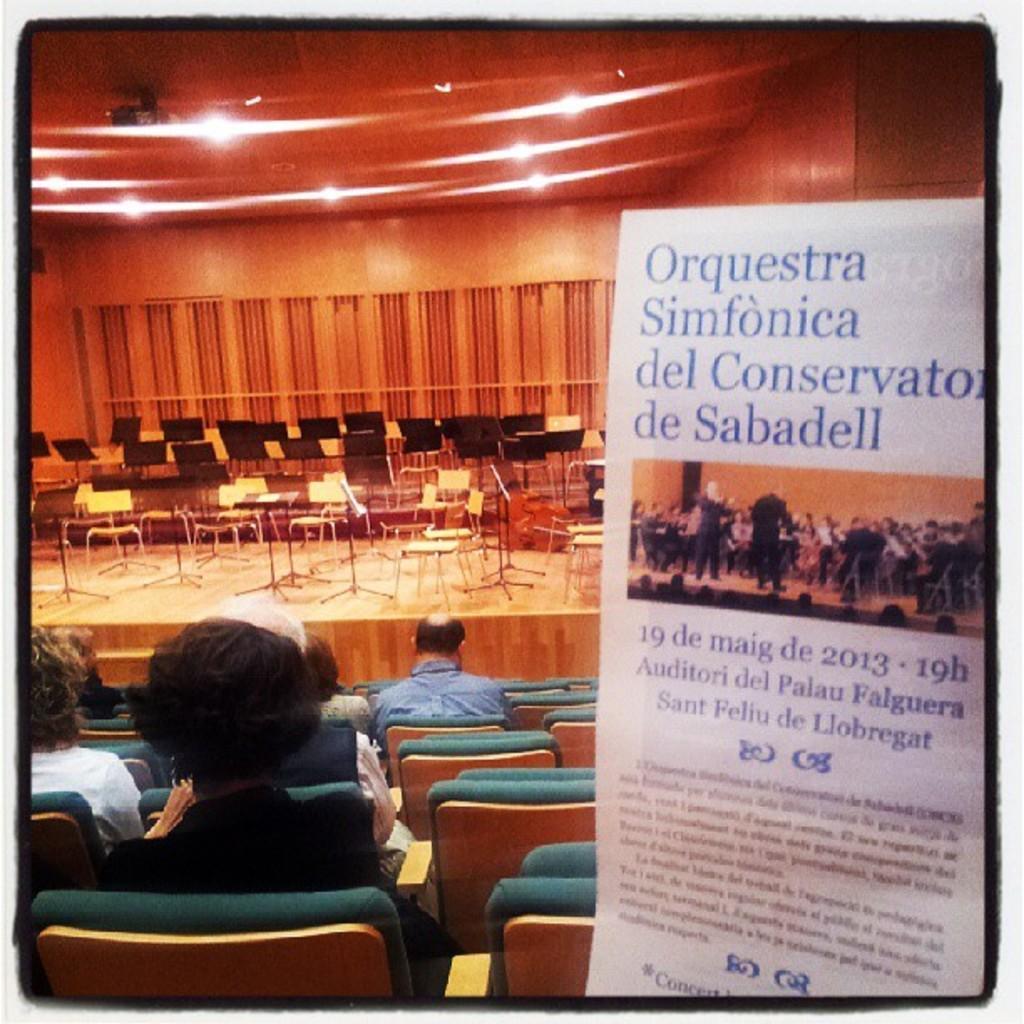How would you summarize this image in a sentence or two? This is a photo and here we can see people sitting on the chairs and in the background, there are some other chairs and we can see a banner, lights and there is a wall. 